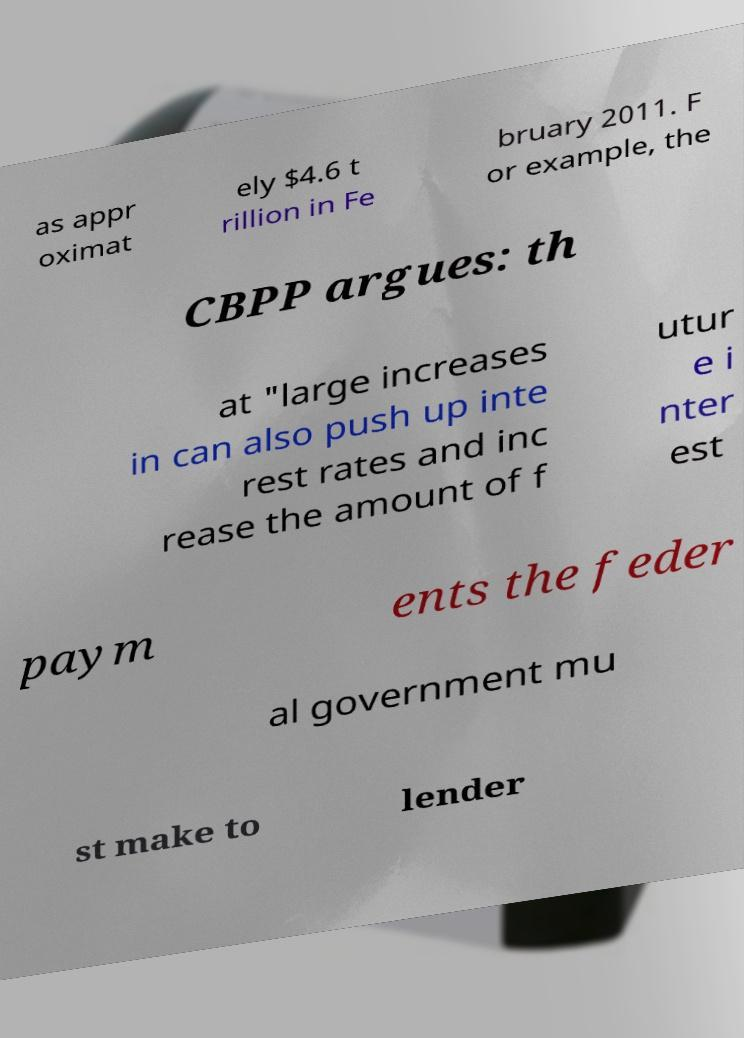For documentation purposes, I need the text within this image transcribed. Could you provide that? as appr oximat ely $4.6 t rillion in Fe bruary 2011. F or example, the CBPP argues: th at "large increases in can also push up inte rest rates and inc rease the amount of f utur e i nter est paym ents the feder al government mu st make to lender 